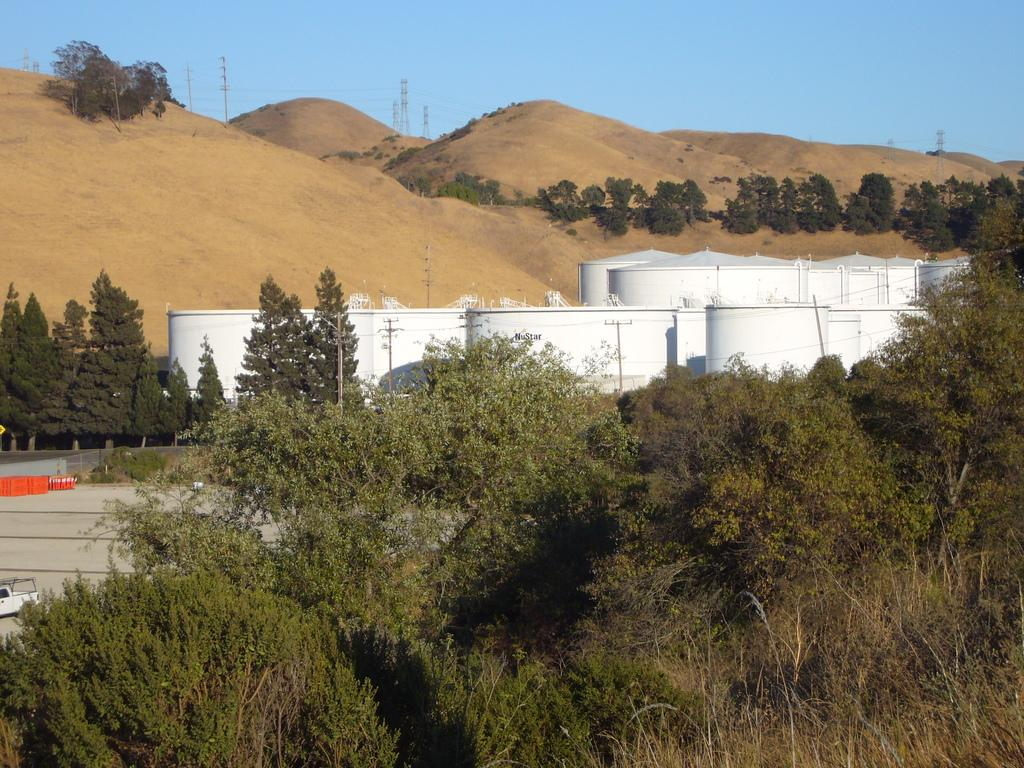What type of natural elements can be seen in the image? There are trees in the image. What type of objects are present in the image? There are containers in the image. What can be seen in the distance in the image? There are towers visible in the background of the image. What color is the silver square in the image? There is no silver square present in the image. How does the slip affect the trees in the image? There is no slip present in the image, so it cannot affect the trees. 